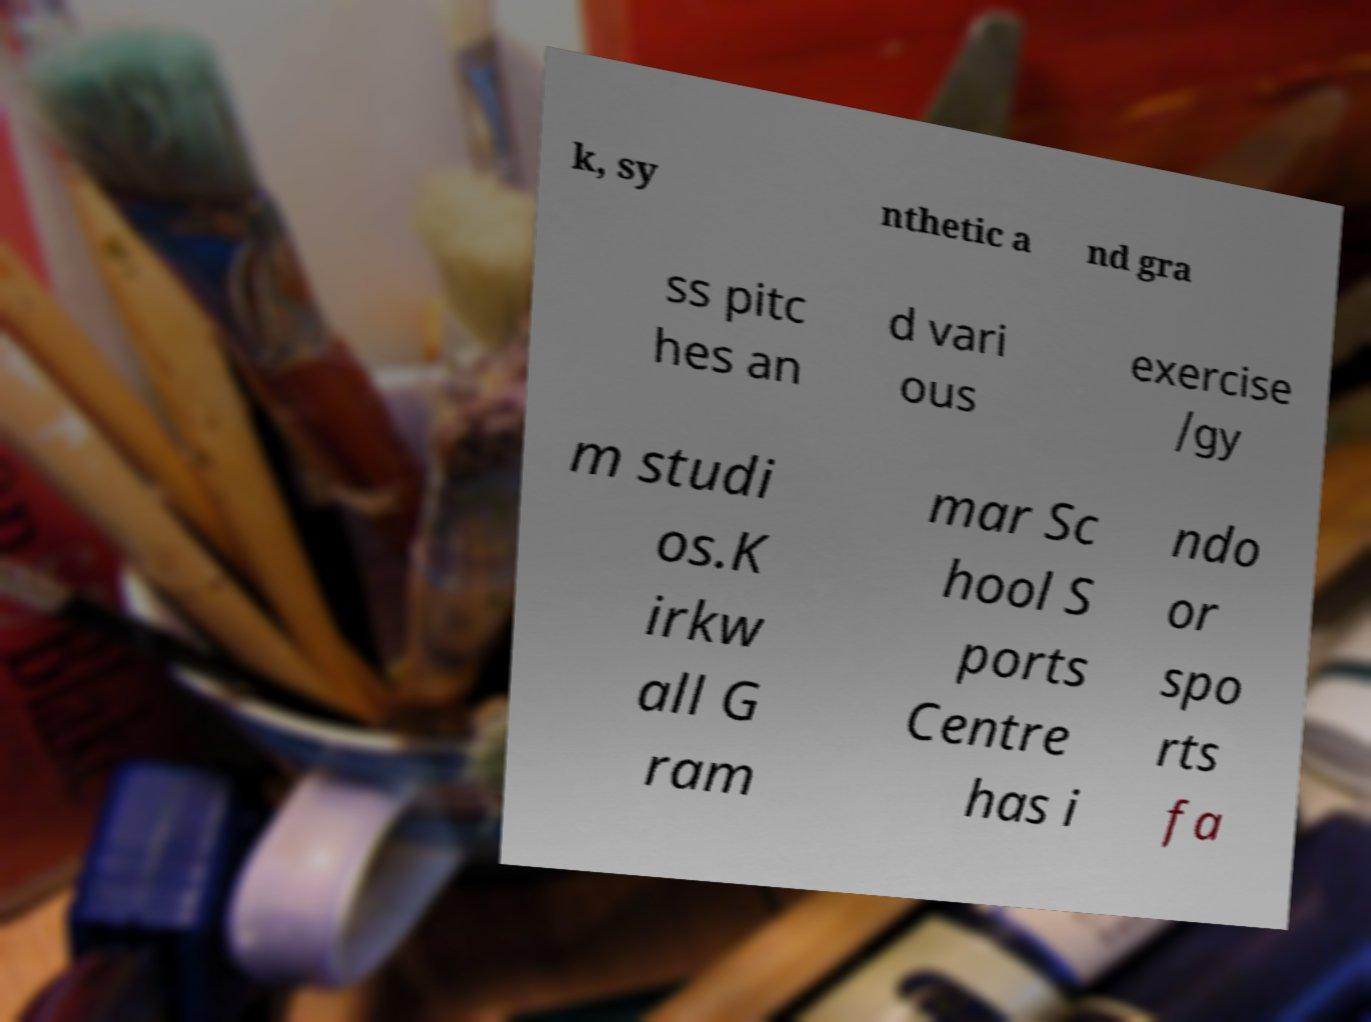What messages or text are displayed in this image? I need them in a readable, typed format. k, sy nthetic a nd gra ss pitc hes an d vari ous exercise /gy m studi os.K irkw all G ram mar Sc hool S ports Centre has i ndo or spo rts fa 